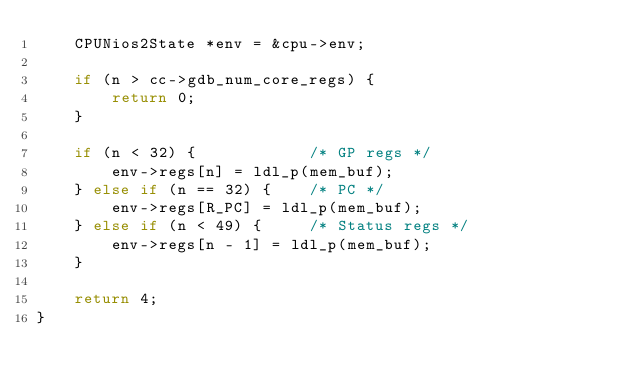<code> <loc_0><loc_0><loc_500><loc_500><_C_>    CPUNios2State *env = &cpu->env;

    if (n > cc->gdb_num_core_regs) {
        return 0;
    }

    if (n < 32) {            /* GP regs */
        env->regs[n] = ldl_p(mem_buf);
    } else if (n == 32) {    /* PC */
        env->regs[R_PC] = ldl_p(mem_buf);
    } else if (n < 49) {     /* Status regs */
        env->regs[n - 1] = ldl_p(mem_buf);
    }

    return 4;
}
</code> 